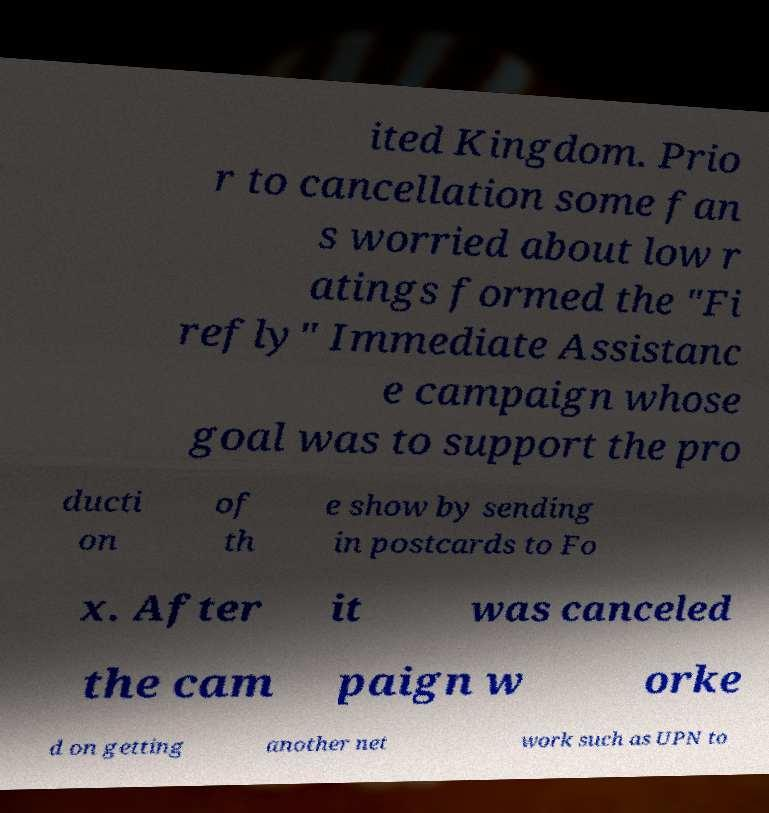Can you accurately transcribe the text from the provided image for me? ited Kingdom. Prio r to cancellation some fan s worried about low r atings formed the "Fi refly" Immediate Assistanc e campaign whose goal was to support the pro ducti on of th e show by sending in postcards to Fo x. After it was canceled the cam paign w orke d on getting another net work such as UPN to 